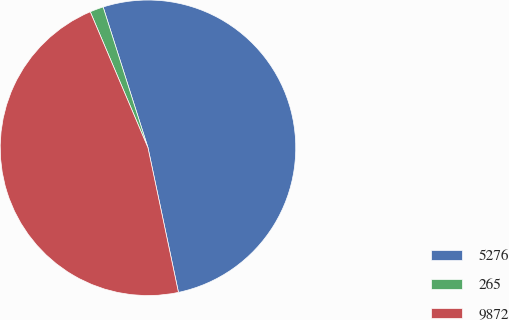Convert chart to OTSL. <chart><loc_0><loc_0><loc_500><loc_500><pie_chart><fcel>5276<fcel>265<fcel>9872<nl><fcel>51.61%<fcel>1.48%<fcel>46.92%<nl></chart> 